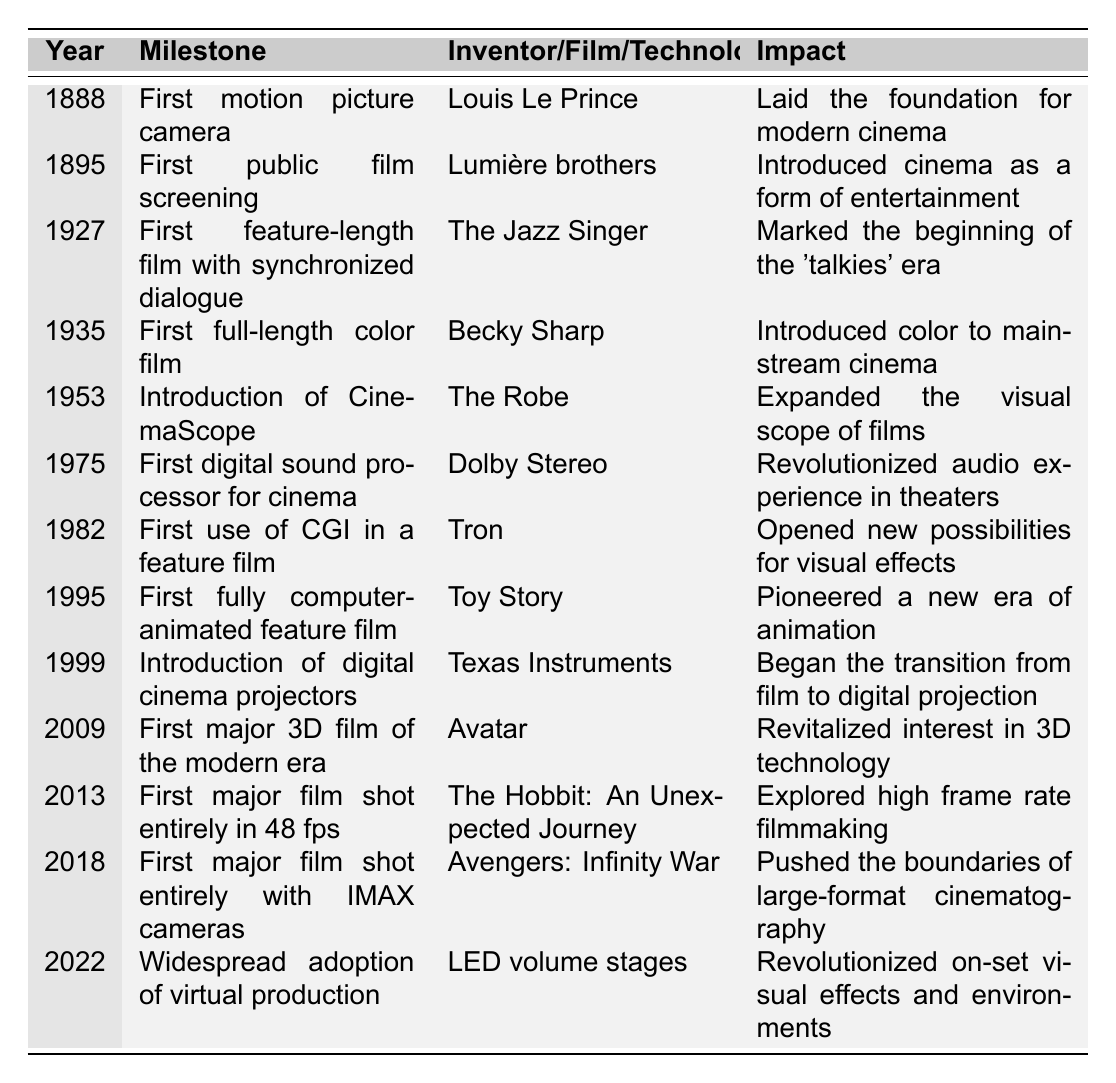What year was the first public film screening? The first public film screening occurred in 1895, as noted in the table under the year and milestone column.
Answer: 1895 Who invented the first motion picture camera? The first motion picture camera was invented by Louis Le Prince, which is stated in the table in the respective columns.
Answer: Louis Le Prince What is the impact of the film 'Avatar'? The impact of 'Avatar', released in 2009, is that it revitalized interest in 3D technology, as mentioned in the table.
Answer: Revitalized interest in 3D technology Which film marked the beginning of the 'talkies' era? 'The Jazz Singer', released in 1927, marked the beginning of the 'talkies' era, indicated in the film column in the table.
Answer: The Jazz Singer How many major technological milestones occurred before 1950? The years listed before 1950 are 1888, 1895, 1927, 1935, and 1953, totaling five milestones. Therefore, the answer is simply the count of these entries.
Answer: 5 Was 'Tron' the first feature film to use CGI? Yes, 'Tron', released in 1982, was the first use of CGI in a feature film, as stated in the table.
Answer: Yes What are the years when significant advancements in audio technology were made? The advancements in audio technology were made in 1975 with the introduction of Dolby Stereo (first digital sound processor).
Answer: 1975 What milestone in cinema history occurred in 2013? The milestone in 2013 was the first major film shot entirely in 48 fps, which was 'The Hobbit: An Unexpected Journey' noted in the table.
Answer: The Hobbit: An Unexpected Journey Which milestone led to the introduction of color in mainstream cinema? The milestone that introduced color to mainstream cinema was 'Becky Sharp', the first full-length color film in 1935, as per the table.
Answer: Becky Sharp Which year saw the first fully computer-animated feature film? The first fully computer-animated feature film came out in 1995, as recorded in the table under 'Film'.
Answer: 1995 What was the impact of the first digital sound processor for cinema? The impact was that it revolutionized the audio experience in theaters, as discussed in the impact column of the table.
Answer: Revolutionized audio experience in theaters What type of filmmaking was explored with 'The Hobbit: An Unexpected Journey'? 'The Hobbit: An Unexpected Journey' explored high frame rate filmmaking, indicated in the respective impact column.
Answer: High frame rate filmmaking Are there more milestones related to film than technology? There are the same number of film-related milestones (7) as technology-related milestones (7). Therefore, the answer is no, they are equal.
Answer: No What are the impacts of the technological milestone that was widespread in 2022? The 2022 milestone involves the widespread adoption of virtual production, which revolutionized on-set visual effects and environments according to the table.
Answer: Revolutionized on-set visual effects and environments In what year did Texas Instruments introduce digital cinema projectors? Texas Instruments introduced digital cinema projectors in 1999, as listed in the table.
Answer: 1999 